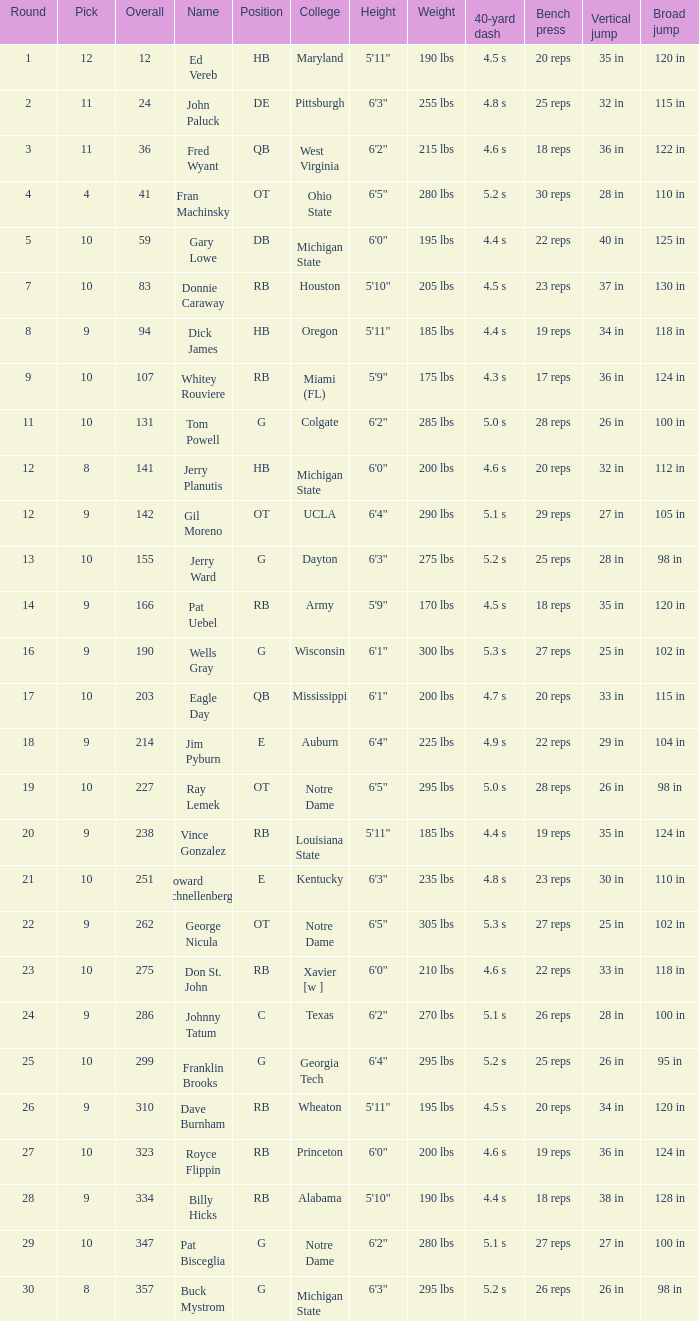What is the total number of overall picks that were after pick 9 and went to Auburn College? 0.0. 